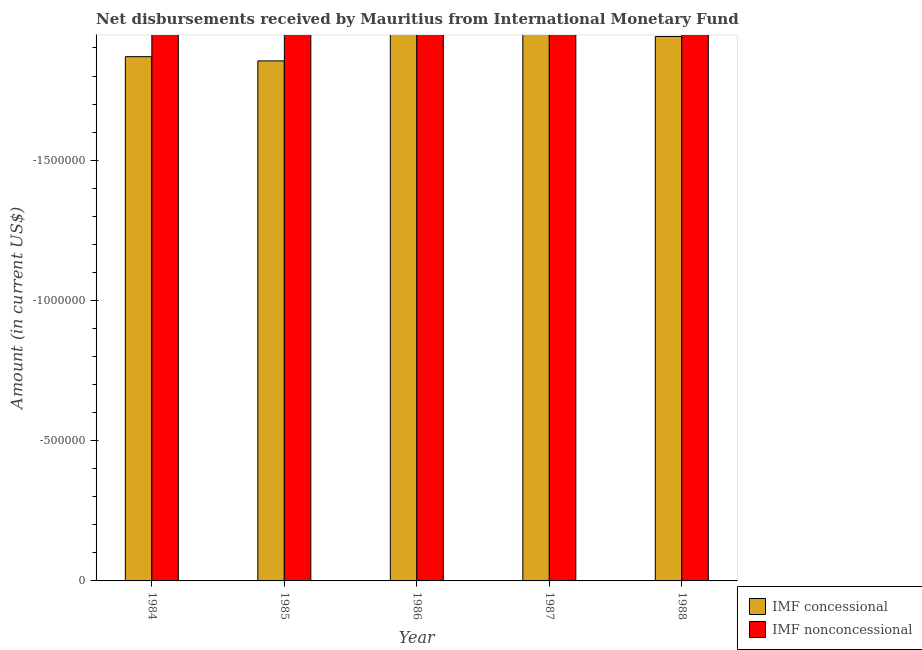How many different coloured bars are there?
Offer a very short reply. 0. Are the number of bars per tick equal to the number of legend labels?
Your answer should be very brief. No. How many bars are there on the 2nd tick from the left?
Offer a very short reply. 0. How many bars are there on the 2nd tick from the right?
Provide a succinct answer. 0. What is the difference between the net concessional disbursements from imf in 1988 and the net non concessional disbursements from imf in 1986?
Provide a short and direct response. 0. Are all the bars in the graph horizontal?
Your response must be concise. No. Does the graph contain any zero values?
Your response must be concise. Yes. Does the graph contain grids?
Your answer should be very brief. No. How many legend labels are there?
Offer a terse response. 2. How are the legend labels stacked?
Keep it short and to the point. Vertical. What is the title of the graph?
Offer a terse response. Net disbursements received by Mauritius from International Monetary Fund. What is the Amount (in current US$) of IMF concessional in 1984?
Keep it short and to the point. 0. What is the Amount (in current US$) of IMF nonconcessional in 1984?
Offer a very short reply. 0. What is the Amount (in current US$) in IMF concessional in 1985?
Give a very brief answer. 0. What is the Amount (in current US$) of IMF concessional in 1987?
Make the answer very short. 0. What is the Amount (in current US$) in IMF concessional in 1988?
Make the answer very short. 0. What is the total Amount (in current US$) of IMF nonconcessional in the graph?
Provide a short and direct response. 0. What is the average Amount (in current US$) of IMF concessional per year?
Provide a short and direct response. 0. What is the average Amount (in current US$) in IMF nonconcessional per year?
Make the answer very short. 0. 